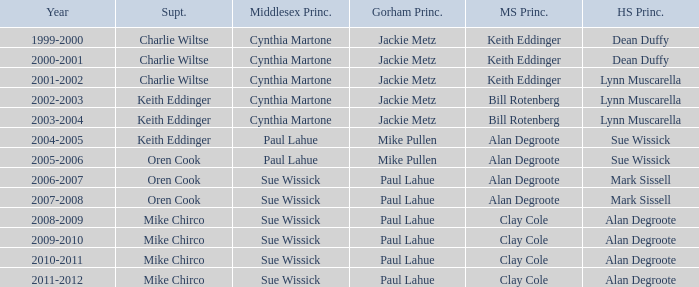Who were the middle school principal(s) in 2010-2011? Clay Cole. 